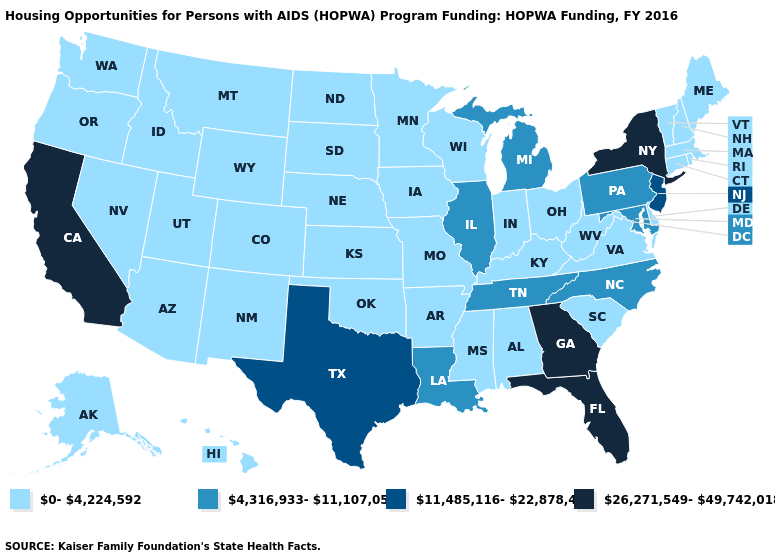What is the value of Louisiana?
Short answer required. 4,316,933-11,107,054. Which states have the lowest value in the Northeast?
Give a very brief answer. Connecticut, Maine, Massachusetts, New Hampshire, Rhode Island, Vermont. Among the states that border New Jersey , which have the highest value?
Concise answer only. New York. Among the states that border Iowa , which have the lowest value?
Answer briefly. Minnesota, Missouri, Nebraska, South Dakota, Wisconsin. What is the value of Colorado?
Be succinct. 0-4,224,592. What is the lowest value in states that border Mississippi?
Answer briefly. 0-4,224,592. What is the highest value in the USA?
Concise answer only. 26,271,549-49,742,018. What is the value of Alabama?
Short answer required. 0-4,224,592. What is the value of Massachusetts?
Answer briefly. 0-4,224,592. Name the states that have a value in the range 11,485,116-22,878,428?
Concise answer only. New Jersey, Texas. Which states have the lowest value in the South?
Be succinct. Alabama, Arkansas, Delaware, Kentucky, Mississippi, Oklahoma, South Carolina, Virginia, West Virginia. Which states hav the highest value in the Northeast?
Quick response, please. New York. Which states have the highest value in the USA?
Answer briefly. California, Florida, Georgia, New York. 